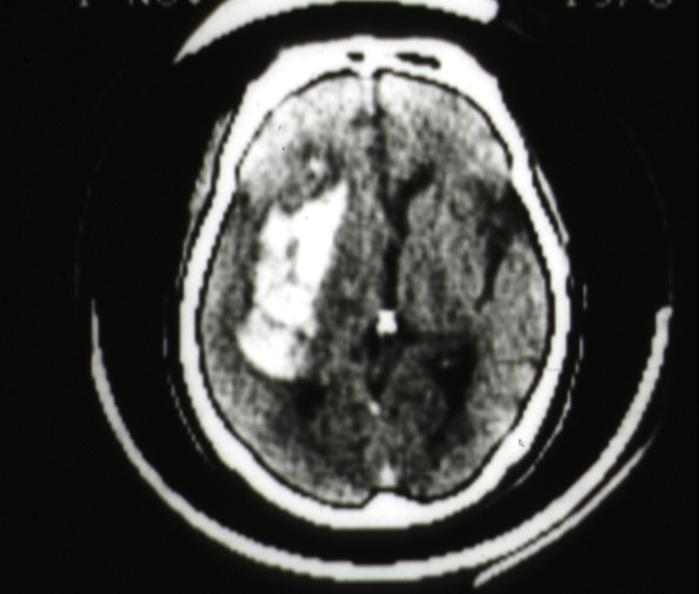s brain present?
Answer the question using a single word or phrase. Yes 